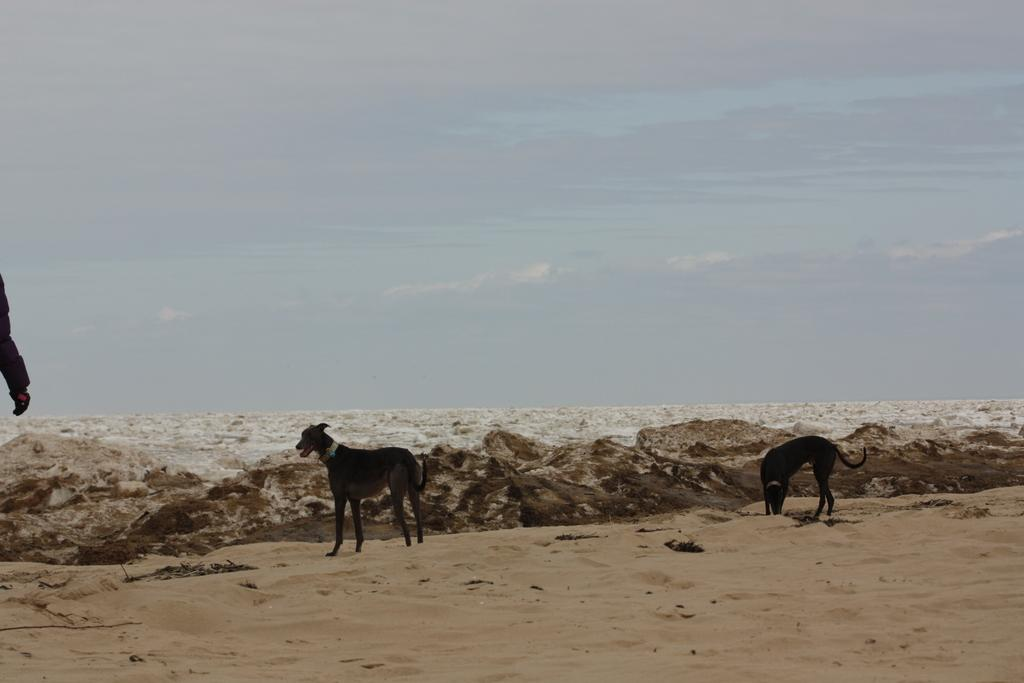How many dogs are present in the image? There are two dogs on the land. What is visible in the background of the image? There is a large water body visible in the background. How would you describe the sky in the image? The sky appears cloudy. What type of airport can be seen in the image? There is no airport present in the image; it features two dogs on the land and a large water body in the background. 